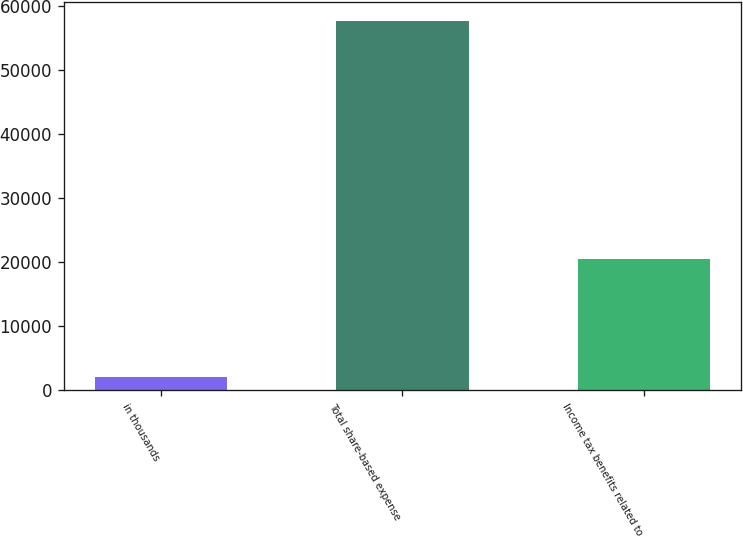<chart> <loc_0><loc_0><loc_500><loc_500><bar_chart><fcel>in thousands<fcel>Total share-based expense<fcel>Income tax benefits related to<nl><fcel>2015<fcel>57716<fcel>20516<nl></chart> 